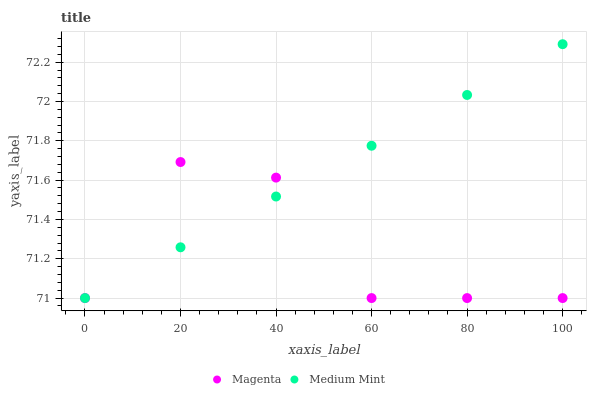Does Magenta have the minimum area under the curve?
Answer yes or no. Yes. Does Medium Mint have the maximum area under the curve?
Answer yes or no. Yes. Does Magenta have the maximum area under the curve?
Answer yes or no. No. Is Medium Mint the smoothest?
Answer yes or no. Yes. Is Magenta the roughest?
Answer yes or no. Yes. Is Magenta the smoothest?
Answer yes or no. No. Does Medium Mint have the lowest value?
Answer yes or no. Yes. Does Medium Mint have the highest value?
Answer yes or no. Yes. Does Magenta have the highest value?
Answer yes or no. No. Does Medium Mint intersect Magenta?
Answer yes or no. Yes. Is Medium Mint less than Magenta?
Answer yes or no. No. Is Medium Mint greater than Magenta?
Answer yes or no. No. 